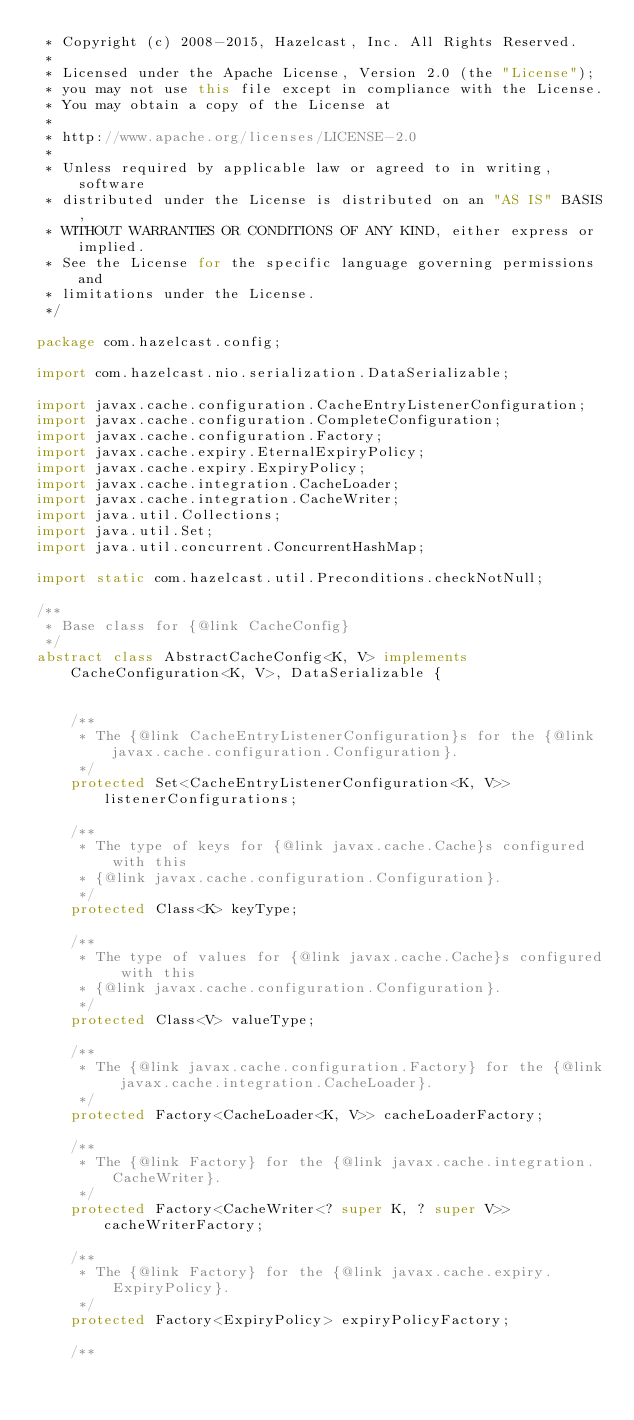Convert code to text. <code><loc_0><loc_0><loc_500><loc_500><_Java_> * Copyright (c) 2008-2015, Hazelcast, Inc. All Rights Reserved.
 *
 * Licensed under the Apache License, Version 2.0 (the "License");
 * you may not use this file except in compliance with the License.
 * You may obtain a copy of the License at
 *
 * http://www.apache.org/licenses/LICENSE-2.0
 *
 * Unless required by applicable law or agreed to in writing, software
 * distributed under the License is distributed on an "AS IS" BASIS,
 * WITHOUT WARRANTIES OR CONDITIONS OF ANY KIND, either express or implied.
 * See the License for the specific language governing permissions and
 * limitations under the License.
 */

package com.hazelcast.config;

import com.hazelcast.nio.serialization.DataSerializable;

import javax.cache.configuration.CacheEntryListenerConfiguration;
import javax.cache.configuration.CompleteConfiguration;
import javax.cache.configuration.Factory;
import javax.cache.expiry.EternalExpiryPolicy;
import javax.cache.expiry.ExpiryPolicy;
import javax.cache.integration.CacheLoader;
import javax.cache.integration.CacheWriter;
import java.util.Collections;
import java.util.Set;
import java.util.concurrent.ConcurrentHashMap;

import static com.hazelcast.util.Preconditions.checkNotNull;

/**
 * Base class for {@link CacheConfig}
 */
abstract class AbstractCacheConfig<K, V> implements CacheConfiguration<K, V>, DataSerializable {


    /**
     * The {@link CacheEntryListenerConfiguration}s for the {@link javax.cache.configuration.Configuration}.
     */
    protected Set<CacheEntryListenerConfiguration<K, V>> listenerConfigurations;

    /**
     * The type of keys for {@link javax.cache.Cache}s configured with this
     * {@link javax.cache.configuration.Configuration}.
     */
    protected Class<K> keyType;

    /**
     * The type of values for {@link javax.cache.Cache}s configured with this
     * {@link javax.cache.configuration.Configuration}.
     */
    protected Class<V> valueType;

    /**
     * The {@link javax.cache.configuration.Factory} for the {@link javax.cache.integration.CacheLoader}.
     */
    protected Factory<CacheLoader<K, V>> cacheLoaderFactory;

    /**
     * The {@link Factory} for the {@link javax.cache.integration.CacheWriter}.
     */
    protected Factory<CacheWriter<? super K, ? super V>> cacheWriterFactory;

    /**
     * The {@link Factory} for the {@link javax.cache.expiry.ExpiryPolicy}.
     */
    protected Factory<ExpiryPolicy> expiryPolicyFactory;

    /**</code> 